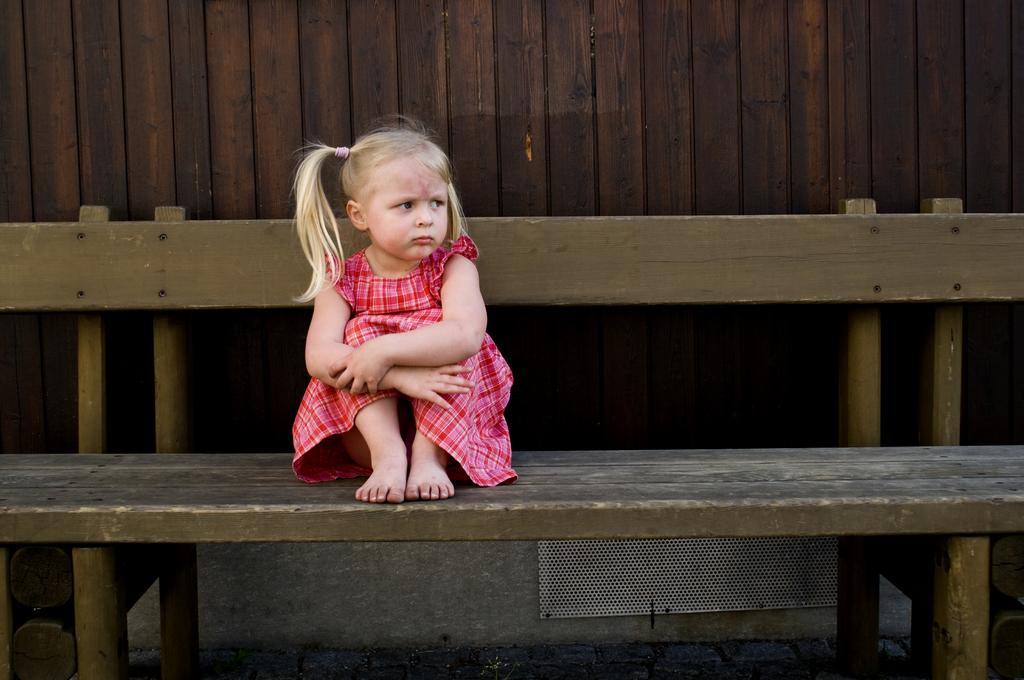Describe this image in one or two sentences. This kid wore red color frock and sitting on this bench. 